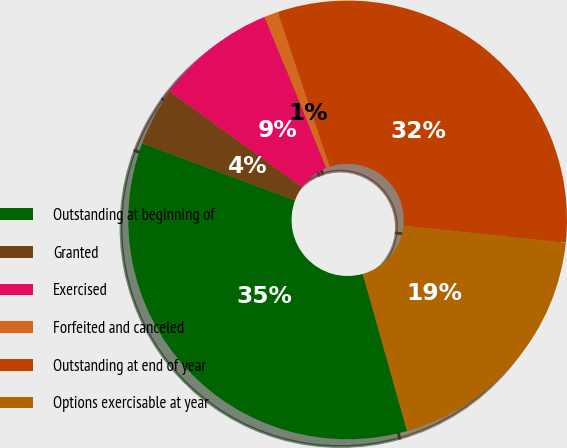Convert chart. <chart><loc_0><loc_0><loc_500><loc_500><pie_chart><fcel>Outstanding at beginning of<fcel>Granted<fcel>Exercised<fcel>Forfeited and canceled<fcel>Outstanding at end of year<fcel>Options exercisable at year<nl><fcel>35.05%<fcel>4.26%<fcel>8.87%<fcel>1.03%<fcel>31.82%<fcel>18.96%<nl></chart> 